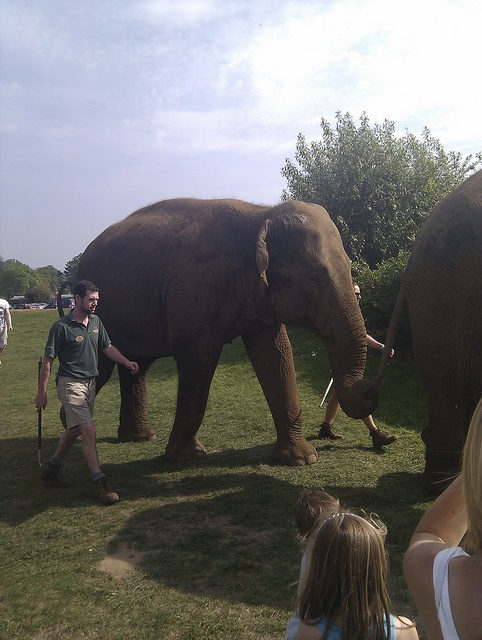Describe the objects in this image and their specific colors. I can see elephant in lavender, black, and gray tones, elephant in lavender, black, and gray tones, people in lavender, black, and gray tones, people in lavender, black, gray, and darkgreen tones, and people in lavender, maroon, gray, and black tones in this image. 